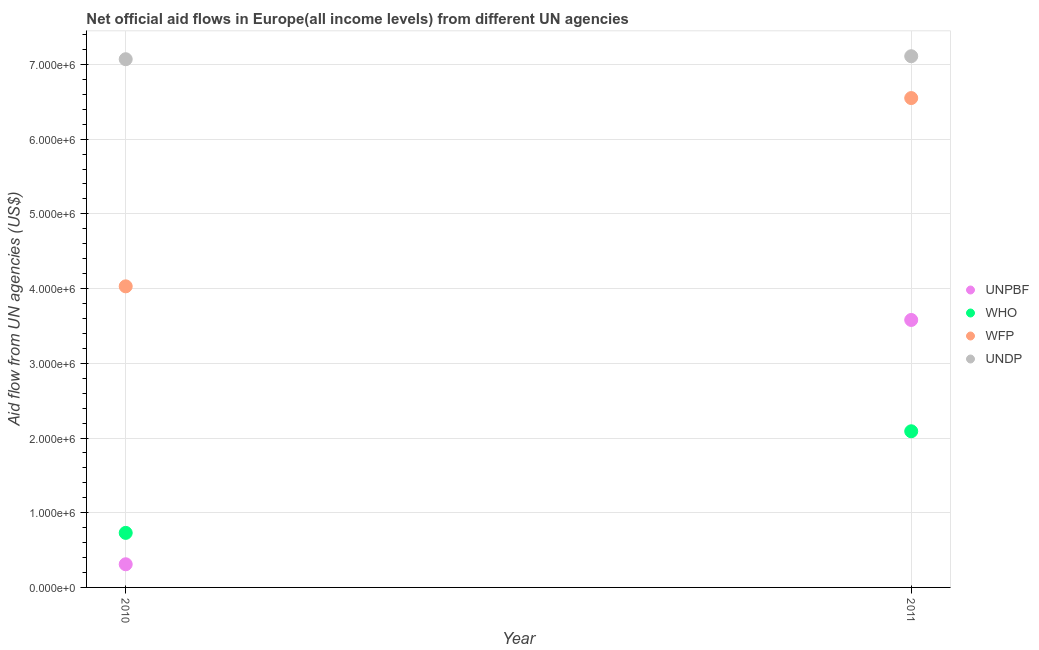Is the number of dotlines equal to the number of legend labels?
Your answer should be compact. Yes. What is the amount of aid given by unpbf in 2011?
Offer a terse response. 3.58e+06. Across all years, what is the maximum amount of aid given by unpbf?
Offer a terse response. 3.58e+06. Across all years, what is the minimum amount of aid given by unpbf?
Provide a succinct answer. 3.10e+05. What is the total amount of aid given by wfp in the graph?
Offer a terse response. 1.06e+07. What is the difference between the amount of aid given by wfp in 2010 and that in 2011?
Offer a terse response. -2.52e+06. What is the difference between the amount of aid given by wfp in 2011 and the amount of aid given by undp in 2010?
Offer a terse response. -5.20e+05. What is the average amount of aid given by wfp per year?
Provide a short and direct response. 5.29e+06. In the year 2011, what is the difference between the amount of aid given by unpbf and amount of aid given by undp?
Provide a succinct answer. -3.53e+06. What is the ratio of the amount of aid given by undp in 2010 to that in 2011?
Your answer should be very brief. 0.99. Is the amount of aid given by undp in 2010 less than that in 2011?
Make the answer very short. Yes. In how many years, is the amount of aid given by who greater than the average amount of aid given by who taken over all years?
Make the answer very short. 1. Is it the case that in every year, the sum of the amount of aid given by wfp and amount of aid given by undp is greater than the sum of amount of aid given by who and amount of aid given by unpbf?
Your response must be concise. No. Is it the case that in every year, the sum of the amount of aid given by unpbf and amount of aid given by who is greater than the amount of aid given by wfp?
Your response must be concise. No. How many dotlines are there?
Provide a short and direct response. 4. Where does the legend appear in the graph?
Your answer should be compact. Center right. How are the legend labels stacked?
Offer a terse response. Vertical. What is the title of the graph?
Your answer should be very brief. Net official aid flows in Europe(all income levels) from different UN agencies. What is the label or title of the X-axis?
Offer a very short reply. Year. What is the label or title of the Y-axis?
Your answer should be compact. Aid flow from UN agencies (US$). What is the Aid flow from UN agencies (US$) of UNPBF in 2010?
Ensure brevity in your answer.  3.10e+05. What is the Aid flow from UN agencies (US$) in WHO in 2010?
Offer a very short reply. 7.30e+05. What is the Aid flow from UN agencies (US$) of WFP in 2010?
Your response must be concise. 4.03e+06. What is the Aid flow from UN agencies (US$) in UNDP in 2010?
Offer a very short reply. 7.07e+06. What is the Aid flow from UN agencies (US$) in UNPBF in 2011?
Your answer should be compact. 3.58e+06. What is the Aid flow from UN agencies (US$) in WHO in 2011?
Provide a short and direct response. 2.09e+06. What is the Aid flow from UN agencies (US$) of WFP in 2011?
Give a very brief answer. 6.55e+06. What is the Aid flow from UN agencies (US$) of UNDP in 2011?
Ensure brevity in your answer.  7.11e+06. Across all years, what is the maximum Aid flow from UN agencies (US$) in UNPBF?
Your answer should be very brief. 3.58e+06. Across all years, what is the maximum Aid flow from UN agencies (US$) in WHO?
Provide a short and direct response. 2.09e+06. Across all years, what is the maximum Aid flow from UN agencies (US$) of WFP?
Provide a succinct answer. 6.55e+06. Across all years, what is the maximum Aid flow from UN agencies (US$) in UNDP?
Provide a succinct answer. 7.11e+06. Across all years, what is the minimum Aid flow from UN agencies (US$) in UNPBF?
Offer a terse response. 3.10e+05. Across all years, what is the minimum Aid flow from UN agencies (US$) in WHO?
Offer a terse response. 7.30e+05. Across all years, what is the minimum Aid flow from UN agencies (US$) of WFP?
Give a very brief answer. 4.03e+06. Across all years, what is the minimum Aid flow from UN agencies (US$) in UNDP?
Offer a terse response. 7.07e+06. What is the total Aid flow from UN agencies (US$) in UNPBF in the graph?
Your response must be concise. 3.89e+06. What is the total Aid flow from UN agencies (US$) in WHO in the graph?
Your response must be concise. 2.82e+06. What is the total Aid flow from UN agencies (US$) in WFP in the graph?
Your answer should be compact. 1.06e+07. What is the total Aid flow from UN agencies (US$) in UNDP in the graph?
Give a very brief answer. 1.42e+07. What is the difference between the Aid flow from UN agencies (US$) in UNPBF in 2010 and that in 2011?
Offer a terse response. -3.27e+06. What is the difference between the Aid flow from UN agencies (US$) of WHO in 2010 and that in 2011?
Offer a very short reply. -1.36e+06. What is the difference between the Aid flow from UN agencies (US$) in WFP in 2010 and that in 2011?
Keep it short and to the point. -2.52e+06. What is the difference between the Aid flow from UN agencies (US$) in UNDP in 2010 and that in 2011?
Give a very brief answer. -4.00e+04. What is the difference between the Aid flow from UN agencies (US$) of UNPBF in 2010 and the Aid flow from UN agencies (US$) of WHO in 2011?
Offer a very short reply. -1.78e+06. What is the difference between the Aid flow from UN agencies (US$) of UNPBF in 2010 and the Aid flow from UN agencies (US$) of WFP in 2011?
Ensure brevity in your answer.  -6.24e+06. What is the difference between the Aid flow from UN agencies (US$) in UNPBF in 2010 and the Aid flow from UN agencies (US$) in UNDP in 2011?
Make the answer very short. -6.80e+06. What is the difference between the Aid flow from UN agencies (US$) in WHO in 2010 and the Aid flow from UN agencies (US$) in WFP in 2011?
Provide a short and direct response. -5.82e+06. What is the difference between the Aid flow from UN agencies (US$) in WHO in 2010 and the Aid flow from UN agencies (US$) in UNDP in 2011?
Your response must be concise. -6.38e+06. What is the difference between the Aid flow from UN agencies (US$) in WFP in 2010 and the Aid flow from UN agencies (US$) in UNDP in 2011?
Your answer should be compact. -3.08e+06. What is the average Aid flow from UN agencies (US$) of UNPBF per year?
Your answer should be compact. 1.94e+06. What is the average Aid flow from UN agencies (US$) in WHO per year?
Ensure brevity in your answer.  1.41e+06. What is the average Aid flow from UN agencies (US$) of WFP per year?
Provide a succinct answer. 5.29e+06. What is the average Aid flow from UN agencies (US$) in UNDP per year?
Give a very brief answer. 7.09e+06. In the year 2010, what is the difference between the Aid flow from UN agencies (US$) of UNPBF and Aid flow from UN agencies (US$) of WHO?
Your answer should be very brief. -4.20e+05. In the year 2010, what is the difference between the Aid flow from UN agencies (US$) in UNPBF and Aid flow from UN agencies (US$) in WFP?
Offer a terse response. -3.72e+06. In the year 2010, what is the difference between the Aid flow from UN agencies (US$) in UNPBF and Aid flow from UN agencies (US$) in UNDP?
Your answer should be compact. -6.76e+06. In the year 2010, what is the difference between the Aid flow from UN agencies (US$) in WHO and Aid flow from UN agencies (US$) in WFP?
Provide a succinct answer. -3.30e+06. In the year 2010, what is the difference between the Aid flow from UN agencies (US$) in WHO and Aid flow from UN agencies (US$) in UNDP?
Your response must be concise. -6.34e+06. In the year 2010, what is the difference between the Aid flow from UN agencies (US$) of WFP and Aid flow from UN agencies (US$) of UNDP?
Provide a succinct answer. -3.04e+06. In the year 2011, what is the difference between the Aid flow from UN agencies (US$) in UNPBF and Aid flow from UN agencies (US$) in WHO?
Offer a very short reply. 1.49e+06. In the year 2011, what is the difference between the Aid flow from UN agencies (US$) in UNPBF and Aid flow from UN agencies (US$) in WFP?
Give a very brief answer. -2.97e+06. In the year 2011, what is the difference between the Aid flow from UN agencies (US$) in UNPBF and Aid flow from UN agencies (US$) in UNDP?
Provide a succinct answer. -3.53e+06. In the year 2011, what is the difference between the Aid flow from UN agencies (US$) of WHO and Aid flow from UN agencies (US$) of WFP?
Provide a succinct answer. -4.46e+06. In the year 2011, what is the difference between the Aid flow from UN agencies (US$) in WHO and Aid flow from UN agencies (US$) in UNDP?
Ensure brevity in your answer.  -5.02e+06. In the year 2011, what is the difference between the Aid flow from UN agencies (US$) in WFP and Aid flow from UN agencies (US$) in UNDP?
Give a very brief answer. -5.60e+05. What is the ratio of the Aid flow from UN agencies (US$) in UNPBF in 2010 to that in 2011?
Offer a terse response. 0.09. What is the ratio of the Aid flow from UN agencies (US$) of WHO in 2010 to that in 2011?
Ensure brevity in your answer.  0.35. What is the ratio of the Aid flow from UN agencies (US$) of WFP in 2010 to that in 2011?
Ensure brevity in your answer.  0.62. What is the difference between the highest and the second highest Aid flow from UN agencies (US$) of UNPBF?
Your response must be concise. 3.27e+06. What is the difference between the highest and the second highest Aid flow from UN agencies (US$) in WHO?
Give a very brief answer. 1.36e+06. What is the difference between the highest and the second highest Aid flow from UN agencies (US$) of WFP?
Keep it short and to the point. 2.52e+06. What is the difference between the highest and the lowest Aid flow from UN agencies (US$) in UNPBF?
Provide a succinct answer. 3.27e+06. What is the difference between the highest and the lowest Aid flow from UN agencies (US$) in WHO?
Make the answer very short. 1.36e+06. What is the difference between the highest and the lowest Aid flow from UN agencies (US$) in WFP?
Provide a short and direct response. 2.52e+06. What is the difference between the highest and the lowest Aid flow from UN agencies (US$) of UNDP?
Offer a terse response. 4.00e+04. 